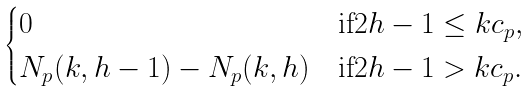Convert formula to latex. <formula><loc_0><loc_0><loc_500><loc_500>\begin{cases} 0 & \text {if} 2 h - 1 \leq k c _ { p } , \\ N _ { p } ( k , h - 1 ) - N _ { p } ( k , h ) & \text {if} 2 h - 1 > k c _ { p } . \end{cases}</formula> 